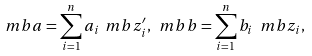<formula> <loc_0><loc_0><loc_500><loc_500>\ m b { a } = \sum _ { i = 1 } ^ { n } a _ { i } \ m b { z ^ { \prime } _ { i } } , \ m b { b } = \sum _ { i = 1 } ^ { n } b _ { i } \ m b { z } _ { i } ,</formula> 